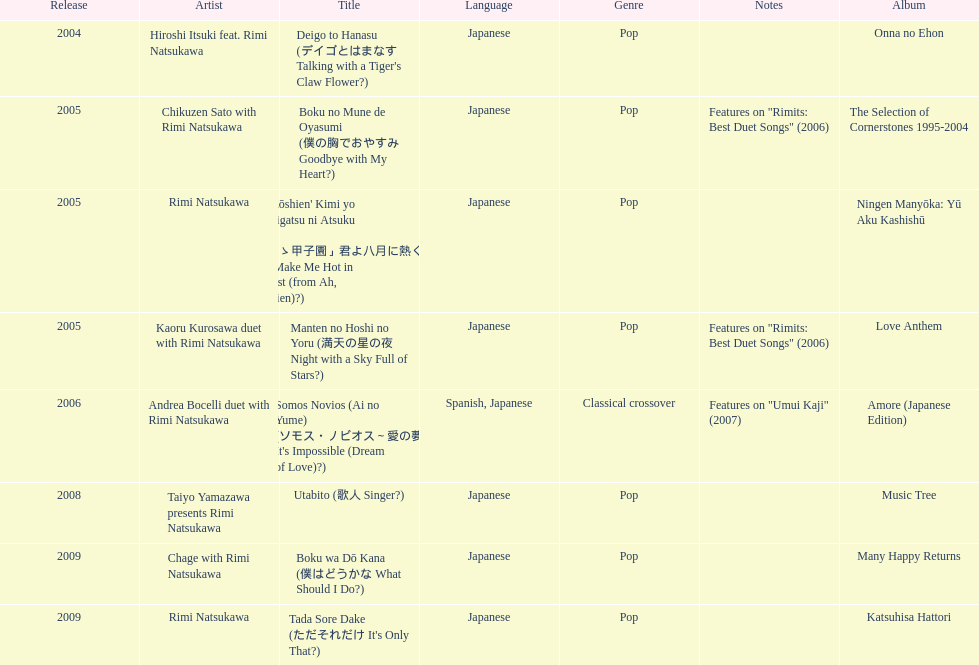What is the number of albums released with the artist rimi natsukawa? 8. 